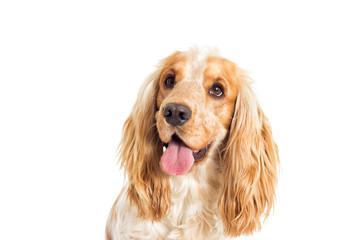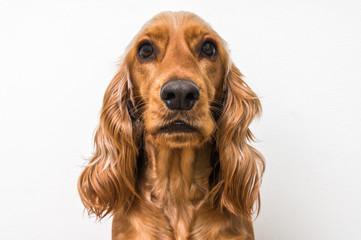The first image is the image on the left, the second image is the image on the right. For the images displayed, is the sentence "An image shows a spaniel looking upward to the right." factually correct? Answer yes or no. No. The first image is the image on the left, the second image is the image on the right. Assess this claim about the two images: "The tongue is out on one of the dog.". Correct or not? Answer yes or no. Yes. 